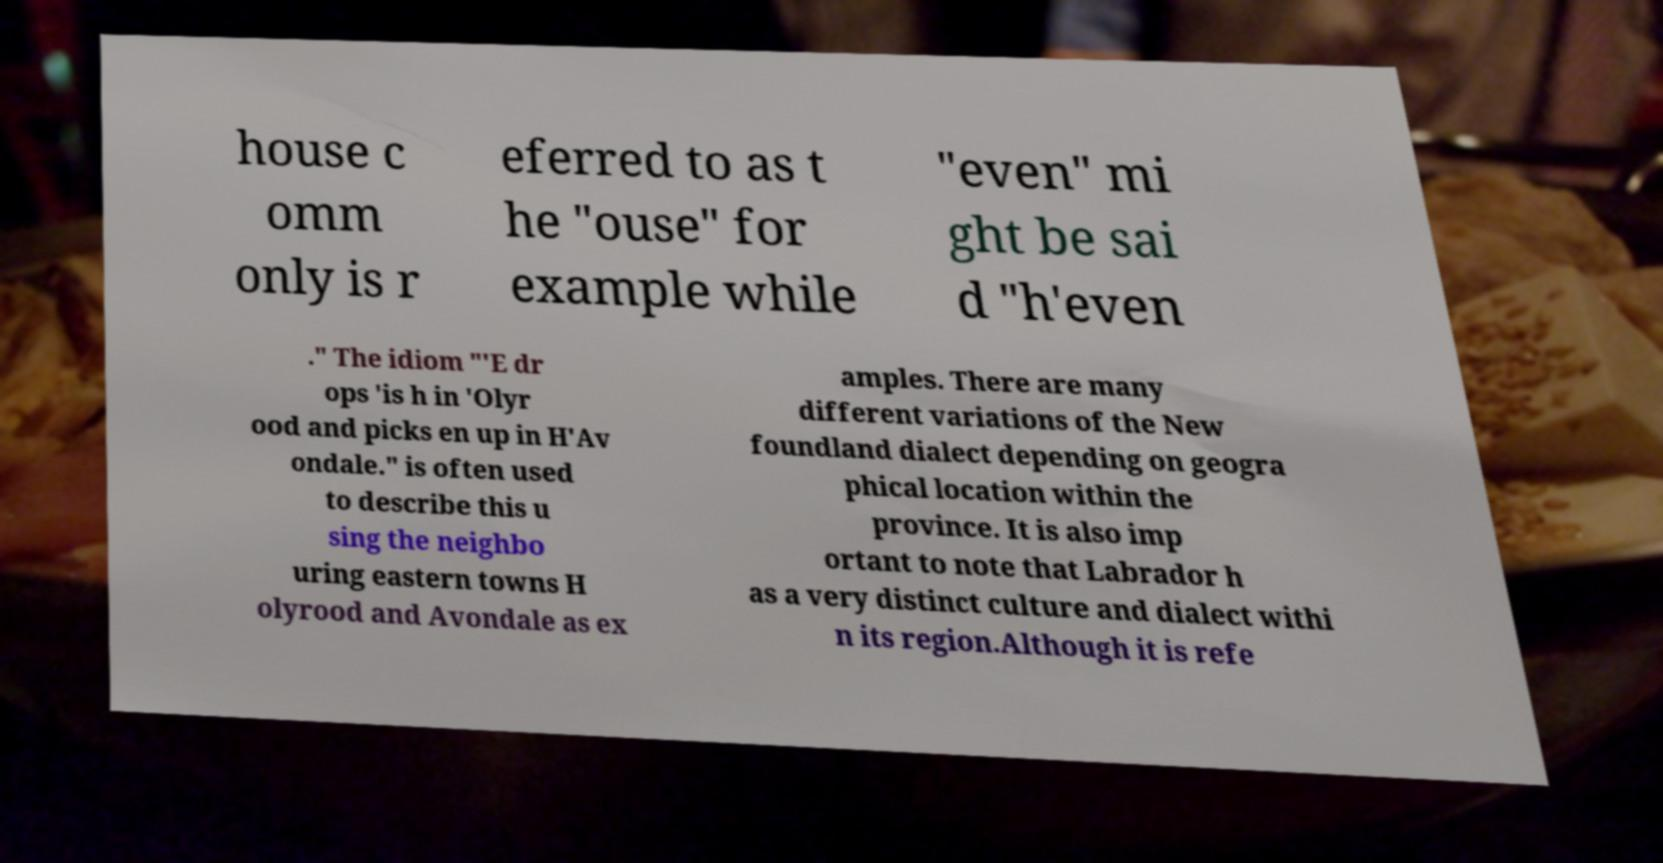There's text embedded in this image that I need extracted. Can you transcribe it verbatim? house c omm only is r eferred to as t he "ouse" for example while "even" mi ght be sai d "h'even ." The idiom "'E dr ops 'is h in 'Olyr ood and picks en up in H'Av ondale." is often used to describe this u sing the neighbo uring eastern towns H olyrood and Avondale as ex amples. There are many different variations of the New foundland dialect depending on geogra phical location within the province. It is also imp ortant to note that Labrador h as a very distinct culture and dialect withi n its region.Although it is refe 